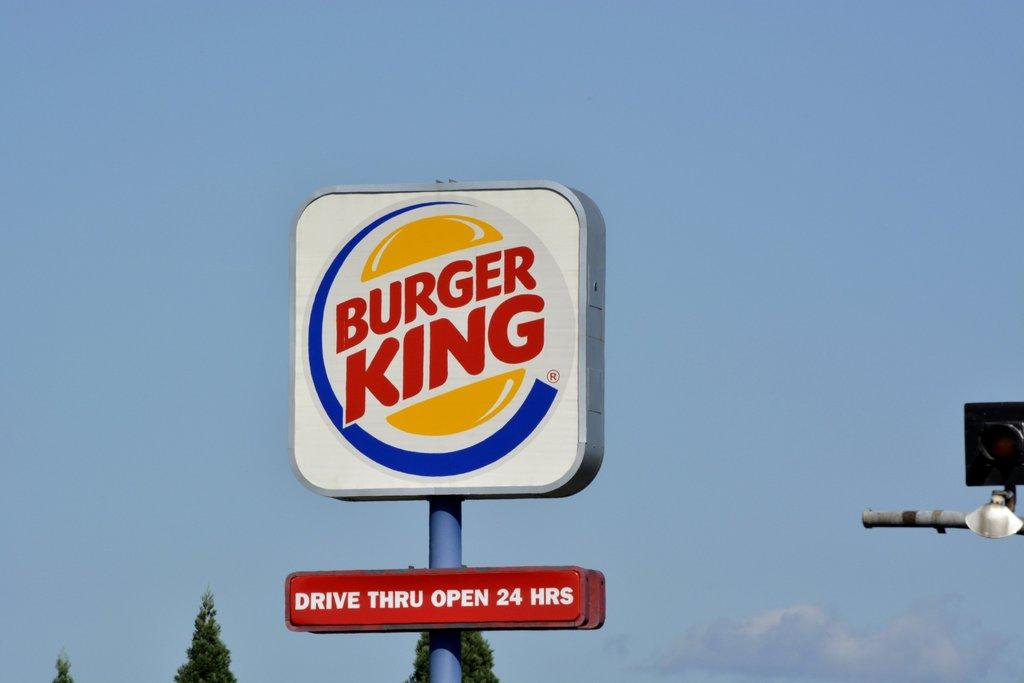<image>
Share a concise interpretation of the image provided. A Burger King sign showing that the drive thru is open 24 hours per day. 